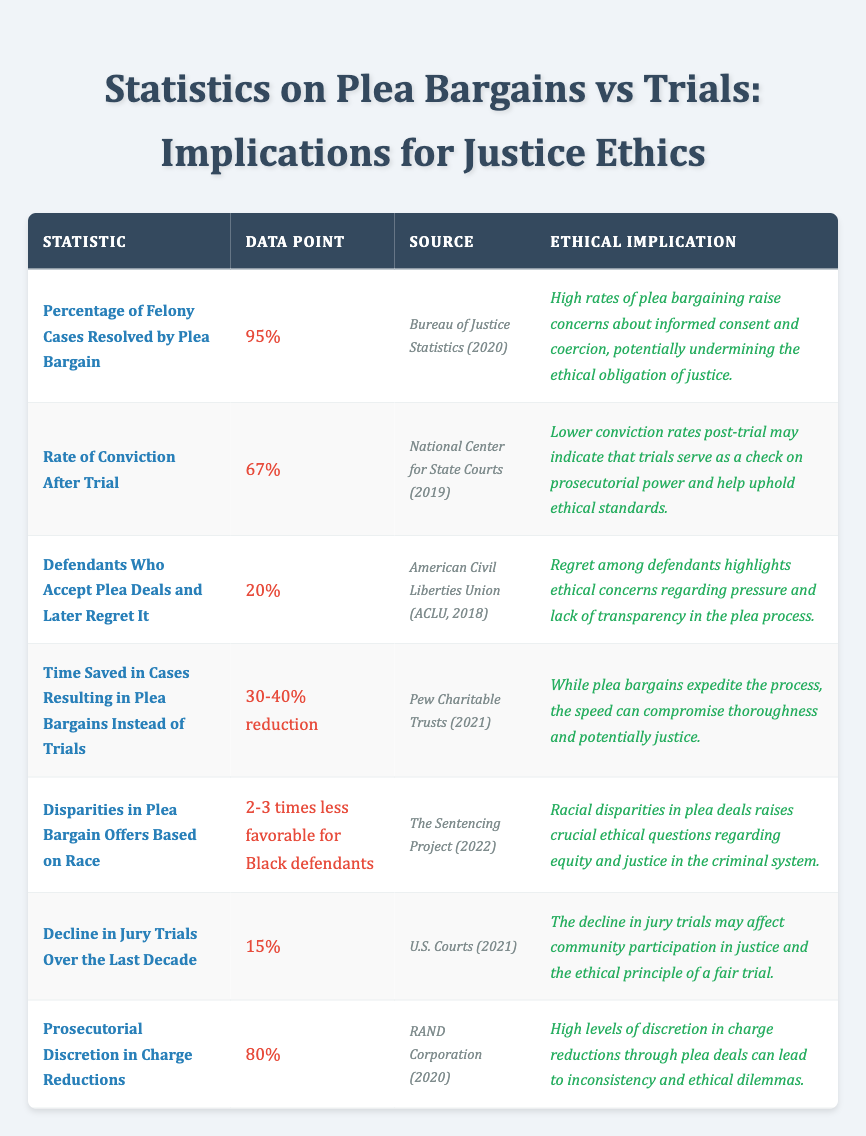What percentage of felony cases are resolved by plea bargain? The table provides a specific data point indicating that 95% of felony cases are resolved through plea bargains.
Answer: 95% According to the table, what is the rate of conviction after trial? The table states that the rate of conviction after trial is 67%.
Answer: 67% Is it true that 20% of defendants who took plea deals later regret their decision? Yes, the table confirms that 20% of defendants who accept plea deals express regret afterwards.
Answer: Yes What is the percentage reduction in time saved when cases result in plea bargains instead of trials? The table indicates a time savings of 30-40% when cases are resolved by plea bargains instead of going to trial.
Answer: 30-40% How much more favorable are plea bargain offers for white defendants compared to Black defendants? The table mentions that plea bargain offers are 2-3 times less favorable for Black defendants, implying that white defendants receive more favorable offers.
Answer: 2-3 times What trend is indicated by the 15% decline in jury trials over the last decade? The table suggests that the decline in jury trials may negatively affect community participation in the justice system, potentially undermining the principle of a fair trial.
Answer: Negative effect on community participation What level of prosecutorial discretion is shown in the data regarding charge reductions? The data point in the table shows an 80% level of prosecutorial discretion in charge reductions through plea deals.
Answer: 80% If plea bargains expedite the legal process but may compromise justice, what ethical concern is highlighted? The table indicates that while plea bargains reduce time, they may compromise thoroughness, raising ethical concerns about the adequacy of justice.
Answer: Compromised thoroughness Considering the implications of plea bargains, how do high rates of such bargains challenge ethical obligations? The table states that high rates of plea bargaining raise concerns about informed consent and coercion, which undermines ethical obligations in justice.
Answer: Undermines ethical obligations Based on the table, what can be inferred about the relationship between race and plea bargains? The disparities in plea bargain offers based on race suggest significant ethical questions regarding equity and fairness in the criminal justice system.
Answer: Significant ethical questions on equity and fairness 